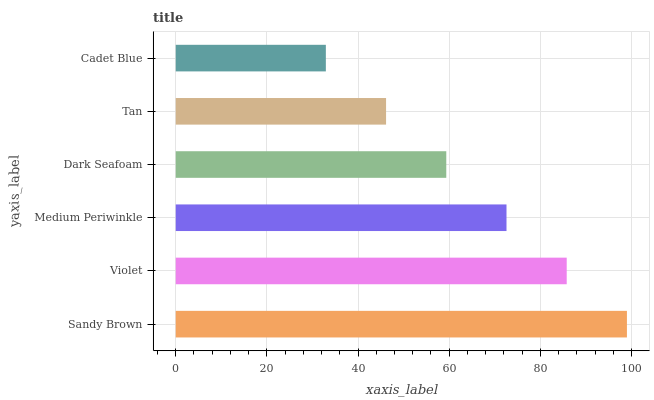Is Cadet Blue the minimum?
Answer yes or no. Yes. Is Sandy Brown the maximum?
Answer yes or no. Yes. Is Violet the minimum?
Answer yes or no. No. Is Violet the maximum?
Answer yes or no. No. Is Sandy Brown greater than Violet?
Answer yes or no. Yes. Is Violet less than Sandy Brown?
Answer yes or no. Yes. Is Violet greater than Sandy Brown?
Answer yes or no. No. Is Sandy Brown less than Violet?
Answer yes or no. No. Is Medium Periwinkle the high median?
Answer yes or no. Yes. Is Dark Seafoam the low median?
Answer yes or no. Yes. Is Violet the high median?
Answer yes or no. No. Is Sandy Brown the low median?
Answer yes or no. No. 